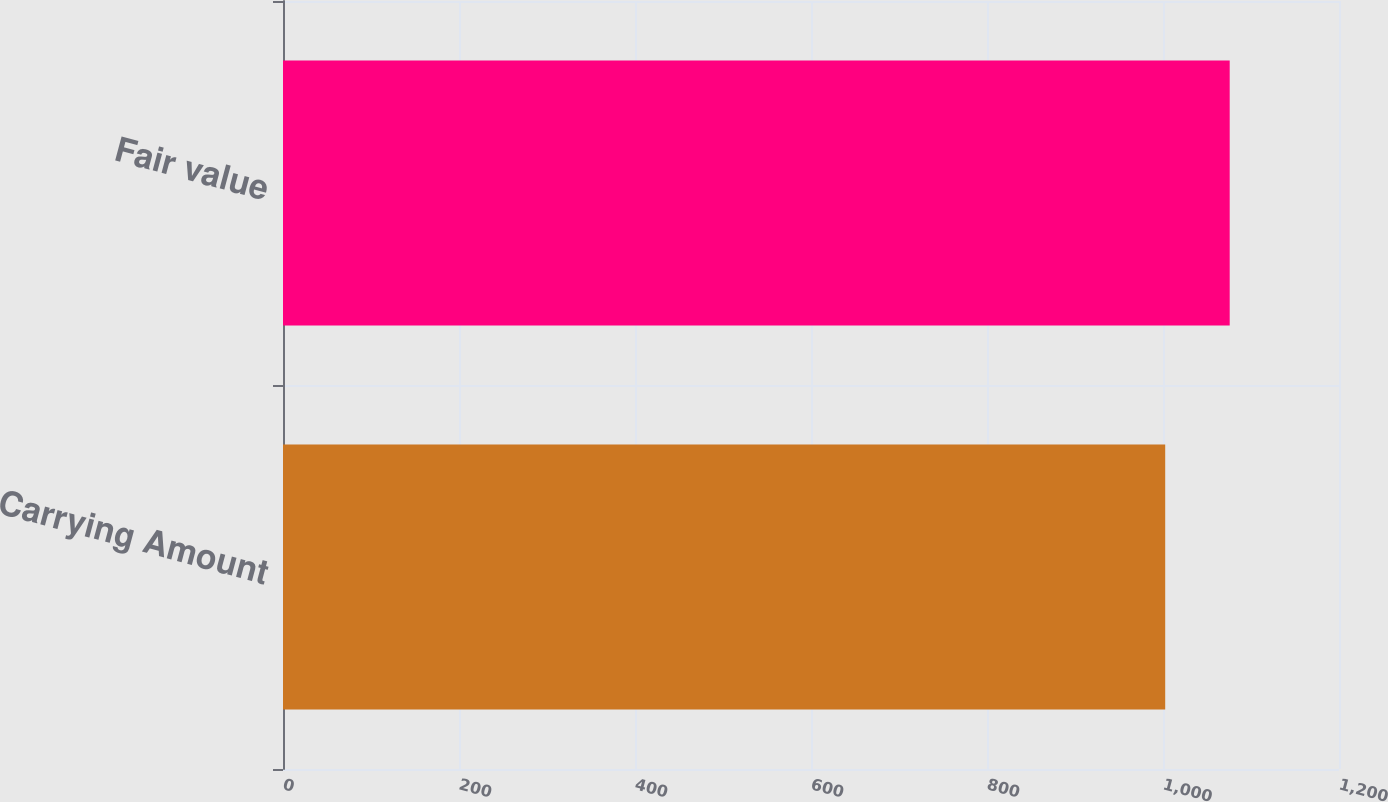Convert chart to OTSL. <chart><loc_0><loc_0><loc_500><loc_500><bar_chart><fcel>Carrying Amount<fcel>Fair value<nl><fcel>1002.5<fcel>1075.8<nl></chart> 